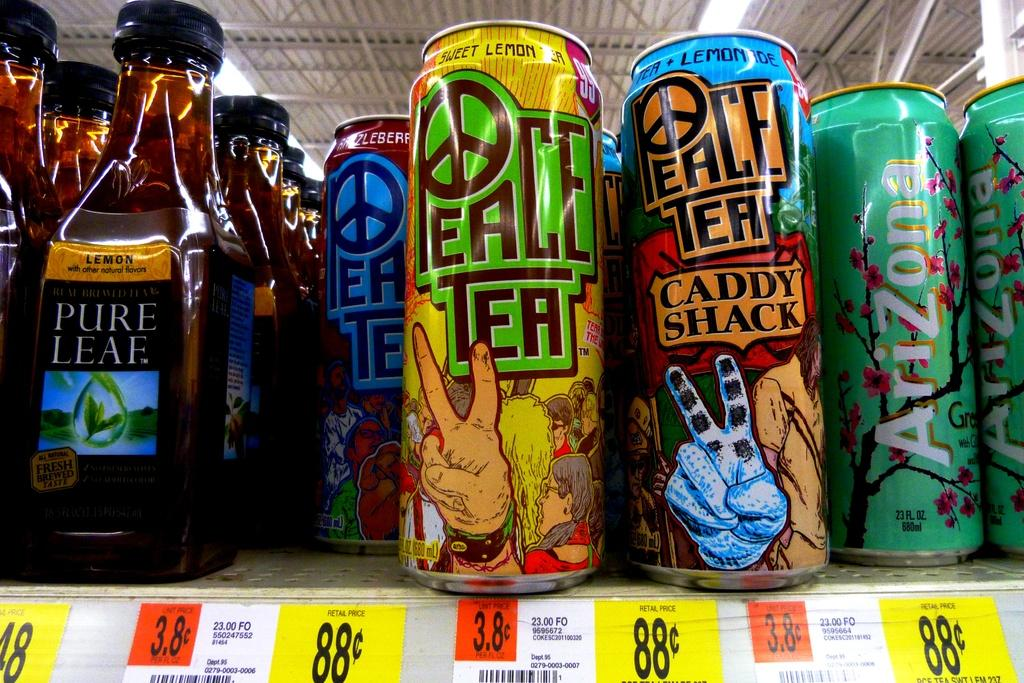<image>
Offer a succinct explanation of the picture presented. Store shelf with aluminum cans of Peace Tea brands in many varieties. 